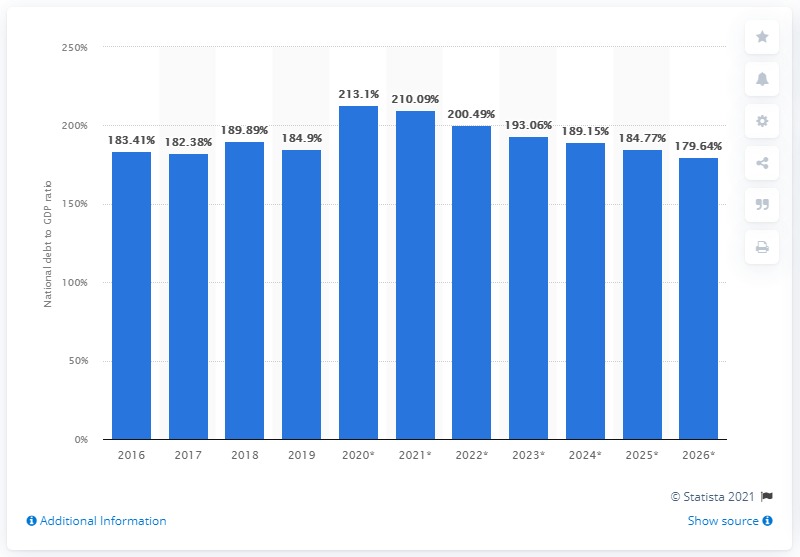Highlight a few significant elements in this photo. In 2019, Greece's national debt represented approximately 184.77% of its GDP. 